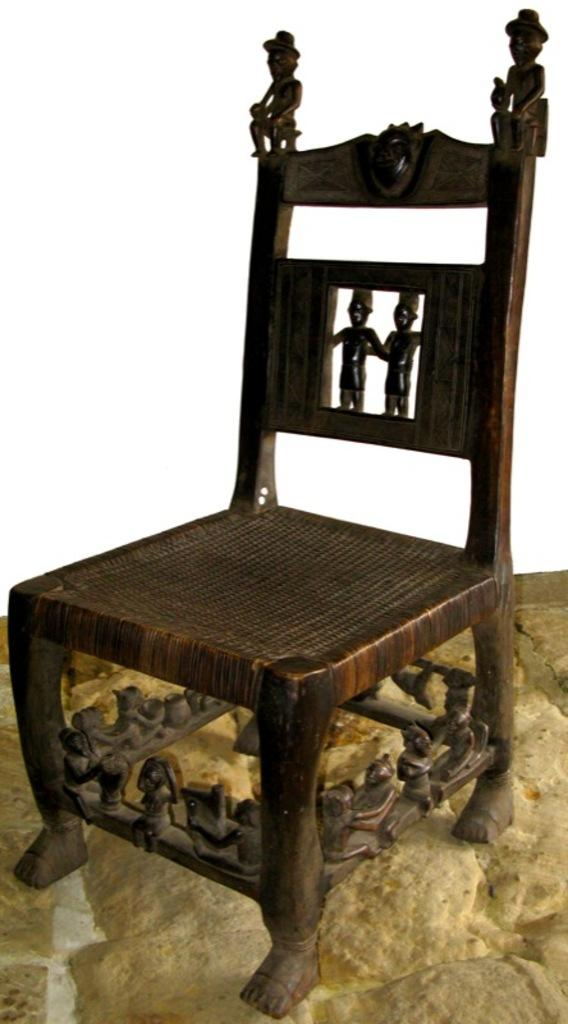What is located in the center of the image? There is an empty chair in the center of the image. Can you describe the chair in the image? The chair is empty and positioned in the center of the image. What type of button is the judge wearing in the image? There is no judge or button present in the image; it only features an empty chair. How is the chair being transported in the image? The chair is not being transported in the image; it is stationary and located in the center of the image. 